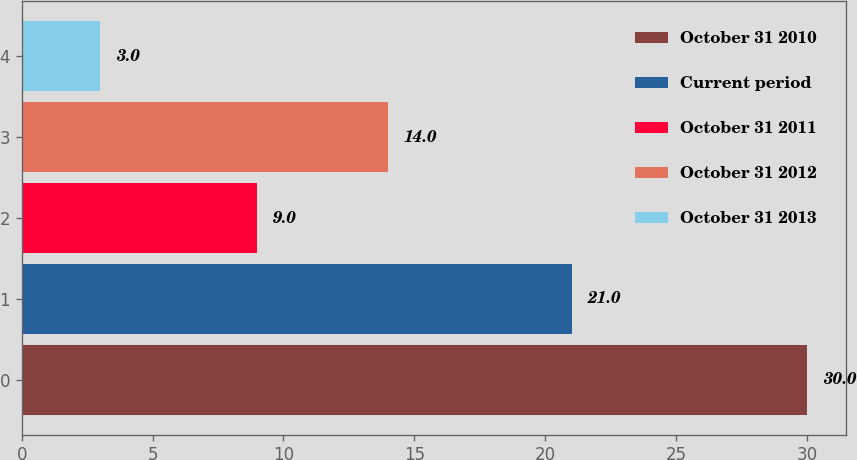Convert chart to OTSL. <chart><loc_0><loc_0><loc_500><loc_500><bar_chart><fcel>October 31 2010<fcel>Current period<fcel>October 31 2011<fcel>October 31 2012<fcel>October 31 2013<nl><fcel>30<fcel>21<fcel>9<fcel>14<fcel>3<nl></chart> 